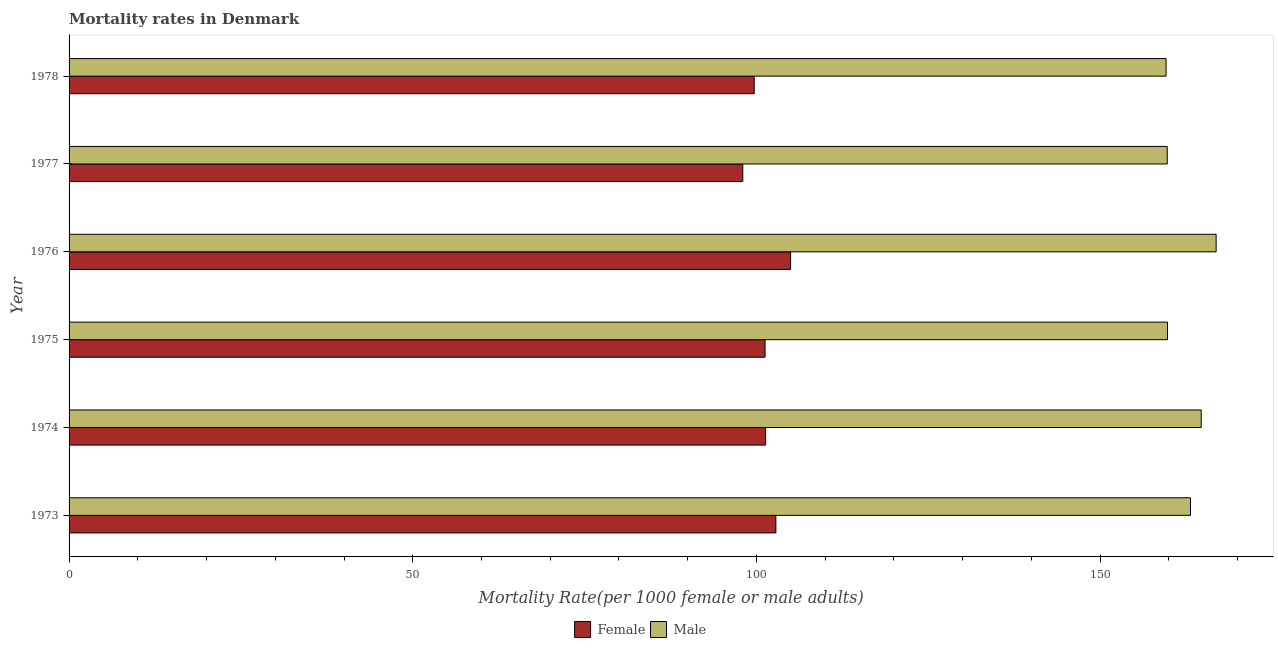How many different coloured bars are there?
Provide a succinct answer. 2. Are the number of bars per tick equal to the number of legend labels?
Offer a terse response. Yes. Are the number of bars on each tick of the Y-axis equal?
Ensure brevity in your answer.  Yes. How many bars are there on the 6th tick from the top?
Your response must be concise. 2. How many bars are there on the 1st tick from the bottom?
Provide a short and direct response. 2. What is the label of the 5th group of bars from the top?
Ensure brevity in your answer.  1974. In how many cases, is the number of bars for a given year not equal to the number of legend labels?
Ensure brevity in your answer.  0. What is the female mortality rate in 1977?
Give a very brief answer. 98.02. Across all years, what is the maximum male mortality rate?
Offer a terse response. 166.88. Across all years, what is the minimum female mortality rate?
Ensure brevity in your answer.  98.02. In which year was the female mortality rate maximum?
Offer a very short reply. 1976. What is the total male mortality rate in the graph?
Provide a succinct answer. 973.92. What is the difference between the male mortality rate in 1976 and that in 1978?
Make the answer very short. 7.28. What is the difference between the female mortality rate in 1976 and the male mortality rate in 1974?
Your answer should be very brief. -59.74. What is the average male mortality rate per year?
Ensure brevity in your answer.  162.32. In the year 1977, what is the difference between the female mortality rate and male mortality rate?
Make the answer very short. -61.75. What is the ratio of the female mortality rate in 1975 to that in 1977?
Provide a short and direct response. 1.03. Is the male mortality rate in 1975 less than that in 1976?
Make the answer very short. Yes. What is the difference between the highest and the second highest male mortality rate?
Your answer should be very brief. 2.17. What is the difference between the highest and the lowest male mortality rate?
Offer a terse response. 7.28. In how many years, is the male mortality rate greater than the average male mortality rate taken over all years?
Provide a short and direct response. 3. Is the sum of the male mortality rate in 1974 and 1978 greater than the maximum female mortality rate across all years?
Make the answer very short. Yes. What does the 1st bar from the top in 1977 represents?
Make the answer very short. Male. What does the 1st bar from the bottom in 1974 represents?
Your answer should be very brief. Female. How many bars are there?
Ensure brevity in your answer.  12. How many years are there in the graph?
Provide a succinct answer. 6. Are the values on the major ticks of X-axis written in scientific E-notation?
Ensure brevity in your answer.  No. Does the graph contain any zero values?
Your response must be concise. No. What is the title of the graph?
Make the answer very short. Mortality rates in Denmark. Does "Current US$" appear as one of the legend labels in the graph?
Your answer should be very brief. No. What is the label or title of the X-axis?
Offer a terse response. Mortality Rate(per 1000 female or male adults). What is the Mortality Rate(per 1000 female or male adults) of Female in 1973?
Your response must be concise. 102.83. What is the Mortality Rate(per 1000 female or male adults) in Male in 1973?
Provide a succinct answer. 163.15. What is the Mortality Rate(per 1000 female or male adults) in Female in 1974?
Make the answer very short. 101.33. What is the Mortality Rate(per 1000 female or male adults) in Male in 1974?
Provide a short and direct response. 164.71. What is the Mortality Rate(per 1000 female or male adults) of Female in 1975?
Offer a terse response. 101.26. What is the Mortality Rate(per 1000 female or male adults) in Male in 1975?
Provide a succinct answer. 159.81. What is the Mortality Rate(per 1000 female or male adults) of Female in 1976?
Provide a succinct answer. 104.97. What is the Mortality Rate(per 1000 female or male adults) in Male in 1976?
Ensure brevity in your answer.  166.88. What is the Mortality Rate(per 1000 female or male adults) of Female in 1977?
Ensure brevity in your answer.  98.02. What is the Mortality Rate(per 1000 female or male adults) in Male in 1977?
Make the answer very short. 159.77. What is the Mortality Rate(per 1000 female or male adults) in Female in 1978?
Provide a short and direct response. 99.67. What is the Mortality Rate(per 1000 female or male adults) of Male in 1978?
Provide a succinct answer. 159.6. Across all years, what is the maximum Mortality Rate(per 1000 female or male adults) in Female?
Provide a short and direct response. 104.97. Across all years, what is the maximum Mortality Rate(per 1000 female or male adults) in Male?
Provide a short and direct response. 166.88. Across all years, what is the minimum Mortality Rate(per 1000 female or male adults) of Female?
Ensure brevity in your answer.  98.02. Across all years, what is the minimum Mortality Rate(per 1000 female or male adults) in Male?
Your response must be concise. 159.6. What is the total Mortality Rate(per 1000 female or male adults) of Female in the graph?
Your answer should be compact. 608.08. What is the total Mortality Rate(per 1000 female or male adults) of Male in the graph?
Your response must be concise. 973.92. What is the difference between the Mortality Rate(per 1000 female or male adults) in Female in 1973 and that in 1974?
Your answer should be compact. 1.49. What is the difference between the Mortality Rate(per 1000 female or male adults) in Male in 1973 and that in 1974?
Your answer should be very brief. -1.56. What is the difference between the Mortality Rate(per 1000 female or male adults) of Female in 1973 and that in 1975?
Your answer should be compact. 1.57. What is the difference between the Mortality Rate(per 1000 female or male adults) in Male in 1973 and that in 1975?
Your answer should be compact. 3.35. What is the difference between the Mortality Rate(per 1000 female or male adults) in Female in 1973 and that in 1976?
Make the answer very short. -2.15. What is the difference between the Mortality Rate(per 1000 female or male adults) of Male in 1973 and that in 1976?
Offer a terse response. -3.73. What is the difference between the Mortality Rate(per 1000 female or male adults) in Female in 1973 and that in 1977?
Ensure brevity in your answer.  4.81. What is the difference between the Mortality Rate(per 1000 female or male adults) of Male in 1973 and that in 1977?
Provide a succinct answer. 3.38. What is the difference between the Mortality Rate(per 1000 female or male adults) in Female in 1973 and that in 1978?
Your response must be concise. 3.15. What is the difference between the Mortality Rate(per 1000 female or male adults) of Male in 1973 and that in 1978?
Keep it short and to the point. 3.56. What is the difference between the Mortality Rate(per 1000 female or male adults) in Female in 1974 and that in 1975?
Provide a succinct answer. 0.08. What is the difference between the Mortality Rate(per 1000 female or male adults) in Male in 1974 and that in 1975?
Ensure brevity in your answer.  4.91. What is the difference between the Mortality Rate(per 1000 female or male adults) in Female in 1974 and that in 1976?
Provide a succinct answer. -3.64. What is the difference between the Mortality Rate(per 1000 female or male adults) of Male in 1974 and that in 1976?
Make the answer very short. -2.17. What is the difference between the Mortality Rate(per 1000 female or male adults) in Female in 1974 and that in 1977?
Your answer should be very brief. 3.32. What is the difference between the Mortality Rate(per 1000 female or male adults) in Male in 1974 and that in 1977?
Offer a very short reply. 4.94. What is the difference between the Mortality Rate(per 1000 female or male adults) of Female in 1974 and that in 1978?
Provide a succinct answer. 1.66. What is the difference between the Mortality Rate(per 1000 female or male adults) of Male in 1974 and that in 1978?
Your answer should be very brief. 5.11. What is the difference between the Mortality Rate(per 1000 female or male adults) in Female in 1975 and that in 1976?
Offer a terse response. -3.72. What is the difference between the Mortality Rate(per 1000 female or male adults) in Male in 1975 and that in 1976?
Keep it short and to the point. -7.08. What is the difference between the Mortality Rate(per 1000 female or male adults) of Female in 1975 and that in 1977?
Give a very brief answer. 3.24. What is the difference between the Mortality Rate(per 1000 female or male adults) of Male in 1975 and that in 1977?
Your response must be concise. 0.04. What is the difference between the Mortality Rate(per 1000 female or male adults) of Female in 1975 and that in 1978?
Make the answer very short. 1.58. What is the difference between the Mortality Rate(per 1000 female or male adults) in Male in 1975 and that in 1978?
Provide a short and direct response. 0.21. What is the difference between the Mortality Rate(per 1000 female or male adults) in Female in 1976 and that in 1977?
Make the answer very short. 6.96. What is the difference between the Mortality Rate(per 1000 female or male adults) of Male in 1976 and that in 1977?
Your answer should be very brief. 7.11. What is the difference between the Mortality Rate(per 1000 female or male adults) of Female in 1976 and that in 1978?
Ensure brevity in your answer.  5.3. What is the difference between the Mortality Rate(per 1000 female or male adults) of Male in 1976 and that in 1978?
Ensure brevity in your answer.  7.28. What is the difference between the Mortality Rate(per 1000 female or male adults) in Female in 1977 and that in 1978?
Ensure brevity in your answer.  -1.66. What is the difference between the Mortality Rate(per 1000 female or male adults) in Male in 1977 and that in 1978?
Provide a short and direct response. 0.17. What is the difference between the Mortality Rate(per 1000 female or male adults) of Female in 1973 and the Mortality Rate(per 1000 female or male adults) of Male in 1974?
Your response must be concise. -61.88. What is the difference between the Mortality Rate(per 1000 female or male adults) of Female in 1973 and the Mortality Rate(per 1000 female or male adults) of Male in 1975?
Keep it short and to the point. -56.98. What is the difference between the Mortality Rate(per 1000 female or male adults) of Female in 1973 and the Mortality Rate(per 1000 female or male adults) of Male in 1976?
Offer a very short reply. -64.06. What is the difference between the Mortality Rate(per 1000 female or male adults) of Female in 1973 and the Mortality Rate(per 1000 female or male adults) of Male in 1977?
Your answer should be compact. -56.94. What is the difference between the Mortality Rate(per 1000 female or male adults) in Female in 1973 and the Mortality Rate(per 1000 female or male adults) in Male in 1978?
Your answer should be very brief. -56.77. What is the difference between the Mortality Rate(per 1000 female or male adults) of Female in 1974 and the Mortality Rate(per 1000 female or male adults) of Male in 1975?
Make the answer very short. -58.47. What is the difference between the Mortality Rate(per 1000 female or male adults) of Female in 1974 and the Mortality Rate(per 1000 female or male adults) of Male in 1976?
Offer a very short reply. -65.55. What is the difference between the Mortality Rate(per 1000 female or male adults) of Female in 1974 and the Mortality Rate(per 1000 female or male adults) of Male in 1977?
Provide a succinct answer. -58.44. What is the difference between the Mortality Rate(per 1000 female or male adults) in Female in 1974 and the Mortality Rate(per 1000 female or male adults) in Male in 1978?
Give a very brief answer. -58.27. What is the difference between the Mortality Rate(per 1000 female or male adults) in Female in 1975 and the Mortality Rate(per 1000 female or male adults) in Male in 1976?
Your response must be concise. -65.63. What is the difference between the Mortality Rate(per 1000 female or male adults) of Female in 1975 and the Mortality Rate(per 1000 female or male adults) of Male in 1977?
Provide a short and direct response. -58.51. What is the difference between the Mortality Rate(per 1000 female or male adults) of Female in 1975 and the Mortality Rate(per 1000 female or male adults) of Male in 1978?
Ensure brevity in your answer.  -58.34. What is the difference between the Mortality Rate(per 1000 female or male adults) of Female in 1976 and the Mortality Rate(per 1000 female or male adults) of Male in 1977?
Your answer should be compact. -54.8. What is the difference between the Mortality Rate(per 1000 female or male adults) of Female in 1976 and the Mortality Rate(per 1000 female or male adults) of Male in 1978?
Your answer should be very brief. -54.63. What is the difference between the Mortality Rate(per 1000 female or male adults) in Female in 1977 and the Mortality Rate(per 1000 female or male adults) in Male in 1978?
Provide a succinct answer. -61.58. What is the average Mortality Rate(per 1000 female or male adults) of Female per year?
Offer a terse response. 101.35. What is the average Mortality Rate(per 1000 female or male adults) of Male per year?
Provide a succinct answer. 162.32. In the year 1973, what is the difference between the Mortality Rate(per 1000 female or male adults) in Female and Mortality Rate(per 1000 female or male adults) in Male?
Your response must be concise. -60.33. In the year 1974, what is the difference between the Mortality Rate(per 1000 female or male adults) of Female and Mortality Rate(per 1000 female or male adults) of Male?
Your response must be concise. -63.38. In the year 1975, what is the difference between the Mortality Rate(per 1000 female or male adults) of Female and Mortality Rate(per 1000 female or male adults) of Male?
Provide a succinct answer. -58.55. In the year 1976, what is the difference between the Mortality Rate(per 1000 female or male adults) of Female and Mortality Rate(per 1000 female or male adults) of Male?
Give a very brief answer. -61.91. In the year 1977, what is the difference between the Mortality Rate(per 1000 female or male adults) in Female and Mortality Rate(per 1000 female or male adults) in Male?
Your response must be concise. -61.75. In the year 1978, what is the difference between the Mortality Rate(per 1000 female or male adults) in Female and Mortality Rate(per 1000 female or male adults) in Male?
Ensure brevity in your answer.  -59.92. What is the ratio of the Mortality Rate(per 1000 female or male adults) of Female in 1973 to that in 1974?
Provide a short and direct response. 1.01. What is the ratio of the Mortality Rate(per 1000 female or male adults) in Male in 1973 to that in 1974?
Your answer should be compact. 0.99. What is the ratio of the Mortality Rate(per 1000 female or male adults) of Female in 1973 to that in 1975?
Offer a very short reply. 1.02. What is the ratio of the Mortality Rate(per 1000 female or male adults) in Male in 1973 to that in 1975?
Provide a succinct answer. 1.02. What is the ratio of the Mortality Rate(per 1000 female or male adults) in Female in 1973 to that in 1976?
Make the answer very short. 0.98. What is the ratio of the Mortality Rate(per 1000 female or male adults) of Male in 1973 to that in 1976?
Ensure brevity in your answer.  0.98. What is the ratio of the Mortality Rate(per 1000 female or male adults) of Female in 1973 to that in 1977?
Keep it short and to the point. 1.05. What is the ratio of the Mortality Rate(per 1000 female or male adults) of Male in 1973 to that in 1977?
Offer a terse response. 1.02. What is the ratio of the Mortality Rate(per 1000 female or male adults) of Female in 1973 to that in 1978?
Give a very brief answer. 1.03. What is the ratio of the Mortality Rate(per 1000 female or male adults) in Male in 1973 to that in 1978?
Provide a succinct answer. 1.02. What is the ratio of the Mortality Rate(per 1000 female or male adults) in Female in 1974 to that in 1975?
Make the answer very short. 1. What is the ratio of the Mortality Rate(per 1000 female or male adults) of Male in 1974 to that in 1975?
Ensure brevity in your answer.  1.03. What is the ratio of the Mortality Rate(per 1000 female or male adults) in Female in 1974 to that in 1976?
Your answer should be compact. 0.97. What is the ratio of the Mortality Rate(per 1000 female or male adults) of Female in 1974 to that in 1977?
Your answer should be very brief. 1.03. What is the ratio of the Mortality Rate(per 1000 female or male adults) in Male in 1974 to that in 1977?
Keep it short and to the point. 1.03. What is the ratio of the Mortality Rate(per 1000 female or male adults) of Female in 1974 to that in 1978?
Give a very brief answer. 1.02. What is the ratio of the Mortality Rate(per 1000 female or male adults) in Male in 1974 to that in 1978?
Make the answer very short. 1.03. What is the ratio of the Mortality Rate(per 1000 female or male adults) in Female in 1975 to that in 1976?
Provide a succinct answer. 0.96. What is the ratio of the Mortality Rate(per 1000 female or male adults) of Male in 1975 to that in 1976?
Provide a short and direct response. 0.96. What is the ratio of the Mortality Rate(per 1000 female or male adults) of Female in 1975 to that in 1977?
Your answer should be compact. 1.03. What is the ratio of the Mortality Rate(per 1000 female or male adults) of Female in 1975 to that in 1978?
Make the answer very short. 1.02. What is the ratio of the Mortality Rate(per 1000 female or male adults) in Male in 1975 to that in 1978?
Offer a very short reply. 1. What is the ratio of the Mortality Rate(per 1000 female or male adults) of Female in 1976 to that in 1977?
Ensure brevity in your answer.  1.07. What is the ratio of the Mortality Rate(per 1000 female or male adults) of Male in 1976 to that in 1977?
Provide a short and direct response. 1.04. What is the ratio of the Mortality Rate(per 1000 female or male adults) in Female in 1976 to that in 1978?
Your answer should be very brief. 1.05. What is the ratio of the Mortality Rate(per 1000 female or male adults) in Male in 1976 to that in 1978?
Provide a short and direct response. 1.05. What is the ratio of the Mortality Rate(per 1000 female or male adults) of Female in 1977 to that in 1978?
Your answer should be very brief. 0.98. What is the ratio of the Mortality Rate(per 1000 female or male adults) in Male in 1977 to that in 1978?
Offer a terse response. 1. What is the difference between the highest and the second highest Mortality Rate(per 1000 female or male adults) in Female?
Make the answer very short. 2.15. What is the difference between the highest and the second highest Mortality Rate(per 1000 female or male adults) of Male?
Your response must be concise. 2.17. What is the difference between the highest and the lowest Mortality Rate(per 1000 female or male adults) in Female?
Offer a terse response. 6.96. What is the difference between the highest and the lowest Mortality Rate(per 1000 female or male adults) in Male?
Your response must be concise. 7.28. 